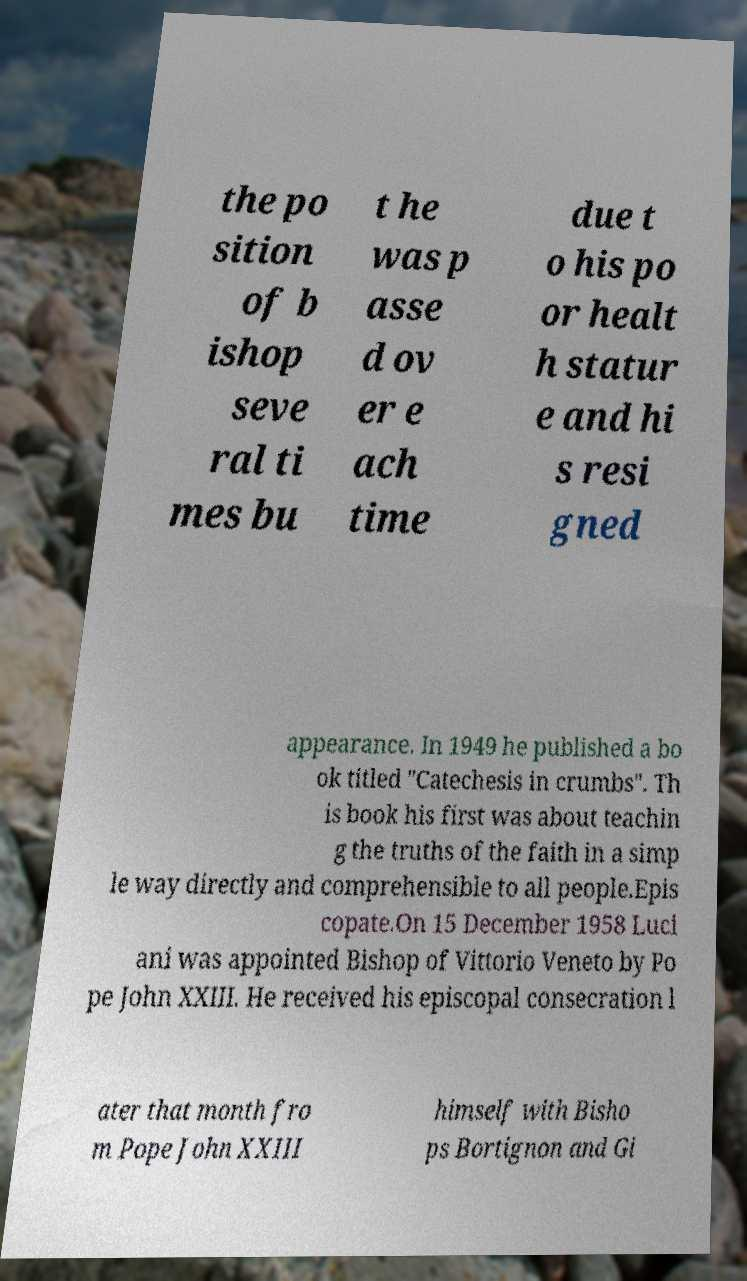For documentation purposes, I need the text within this image transcribed. Could you provide that? the po sition of b ishop seve ral ti mes bu t he was p asse d ov er e ach time due t o his po or healt h statur e and hi s resi gned appearance. In 1949 he published a bo ok titled "Catechesis in crumbs". Th is book his first was about teachin g the truths of the faith in a simp le way directly and comprehensible to all people.Epis copate.On 15 December 1958 Luci ani was appointed Bishop of Vittorio Veneto by Po pe John XXIII. He received his episcopal consecration l ater that month fro m Pope John XXIII himself with Bisho ps Bortignon and Gi 